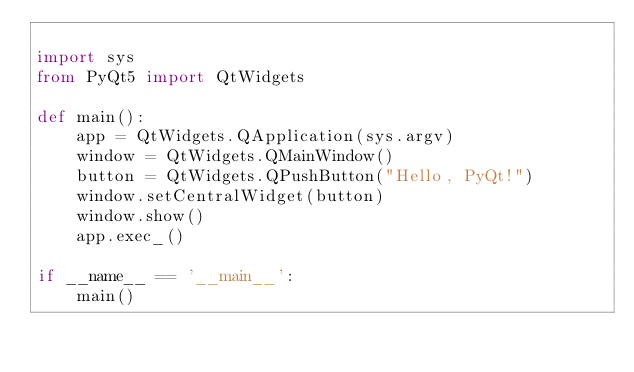Convert code to text. <code><loc_0><loc_0><loc_500><loc_500><_Python_>
import sys
from PyQt5 import QtWidgets

def main():
    app = QtWidgets.QApplication(sys.argv)
    window = QtWidgets.QMainWindow()
    button = QtWidgets.QPushButton("Hello, PyQt!")
    window.setCentralWidget(button)
    window.show()
    app.exec_()

if __name__ == '__main__':
    main()
</code> 